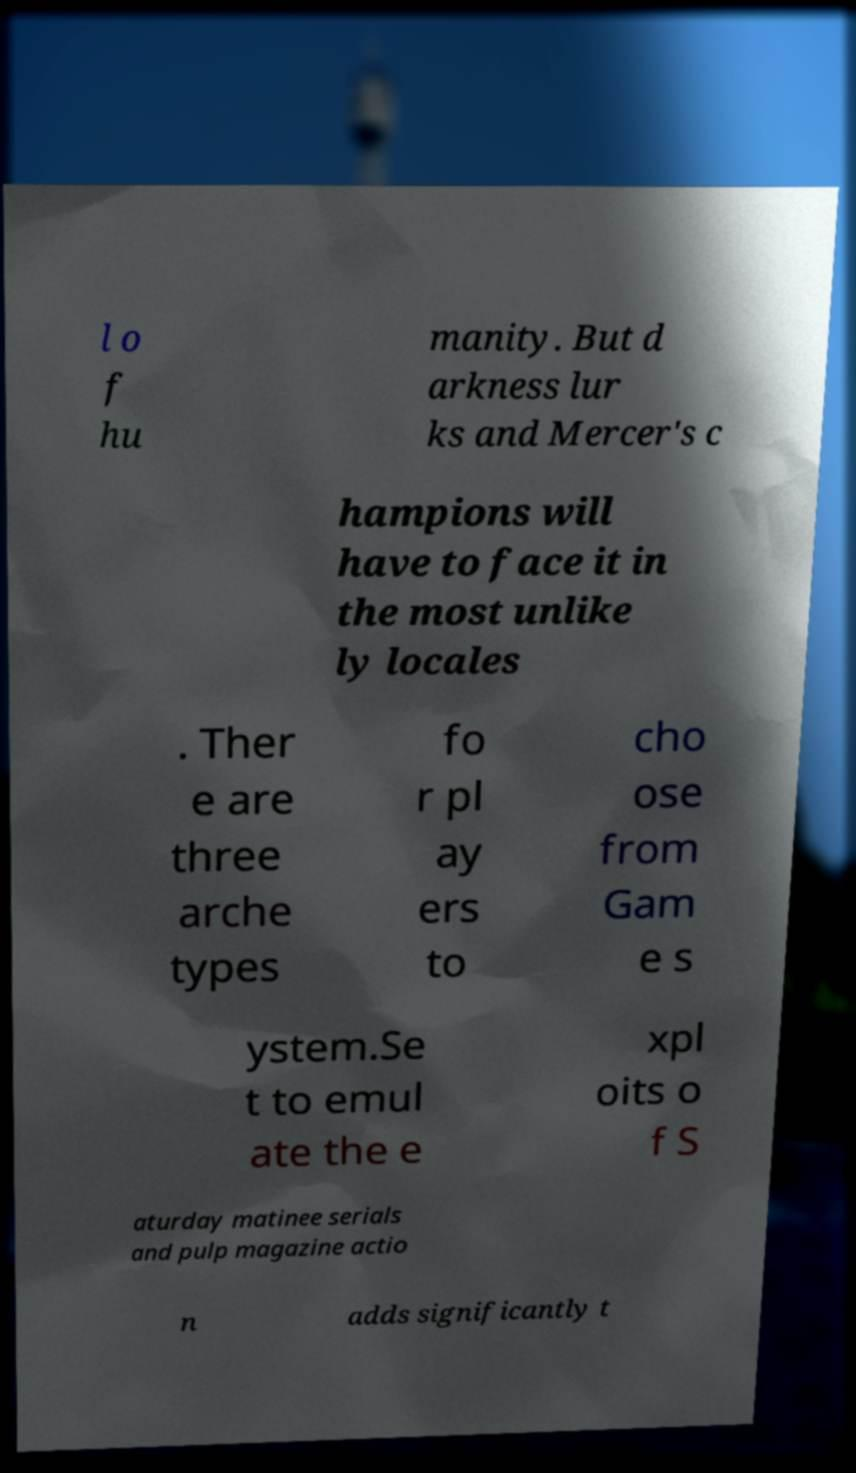Could you assist in decoding the text presented in this image and type it out clearly? l o f hu manity. But d arkness lur ks and Mercer's c hampions will have to face it in the most unlike ly locales . Ther e are three arche types fo r pl ay ers to cho ose from Gam e s ystem.Se t to emul ate the e xpl oits o f S aturday matinee serials and pulp magazine actio n adds significantly t 